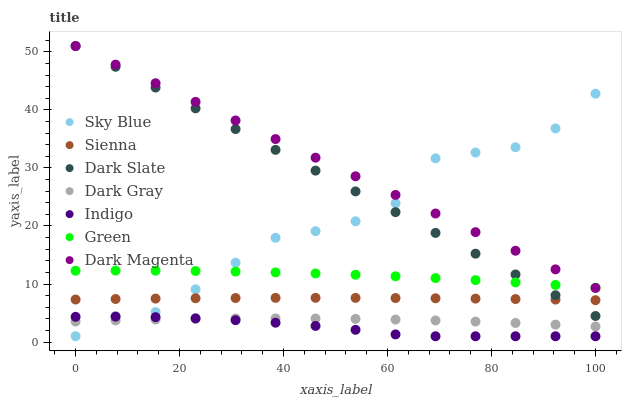Does Indigo have the minimum area under the curve?
Answer yes or no. Yes. Does Dark Magenta have the maximum area under the curve?
Answer yes or no. Yes. Does Dark Magenta have the minimum area under the curve?
Answer yes or no. No. Does Indigo have the maximum area under the curve?
Answer yes or no. No. Is Dark Magenta the smoothest?
Answer yes or no. Yes. Is Sky Blue the roughest?
Answer yes or no. Yes. Is Indigo the smoothest?
Answer yes or no. No. Is Indigo the roughest?
Answer yes or no. No. Does Indigo have the lowest value?
Answer yes or no. Yes. Does Dark Magenta have the lowest value?
Answer yes or no. No. Does Dark Slate have the highest value?
Answer yes or no. Yes. Does Indigo have the highest value?
Answer yes or no. No. Is Dark Gray less than Dark Slate?
Answer yes or no. Yes. Is Sienna greater than Indigo?
Answer yes or no. Yes. Does Dark Magenta intersect Dark Slate?
Answer yes or no. Yes. Is Dark Magenta less than Dark Slate?
Answer yes or no. No. Is Dark Magenta greater than Dark Slate?
Answer yes or no. No. Does Dark Gray intersect Dark Slate?
Answer yes or no. No. 